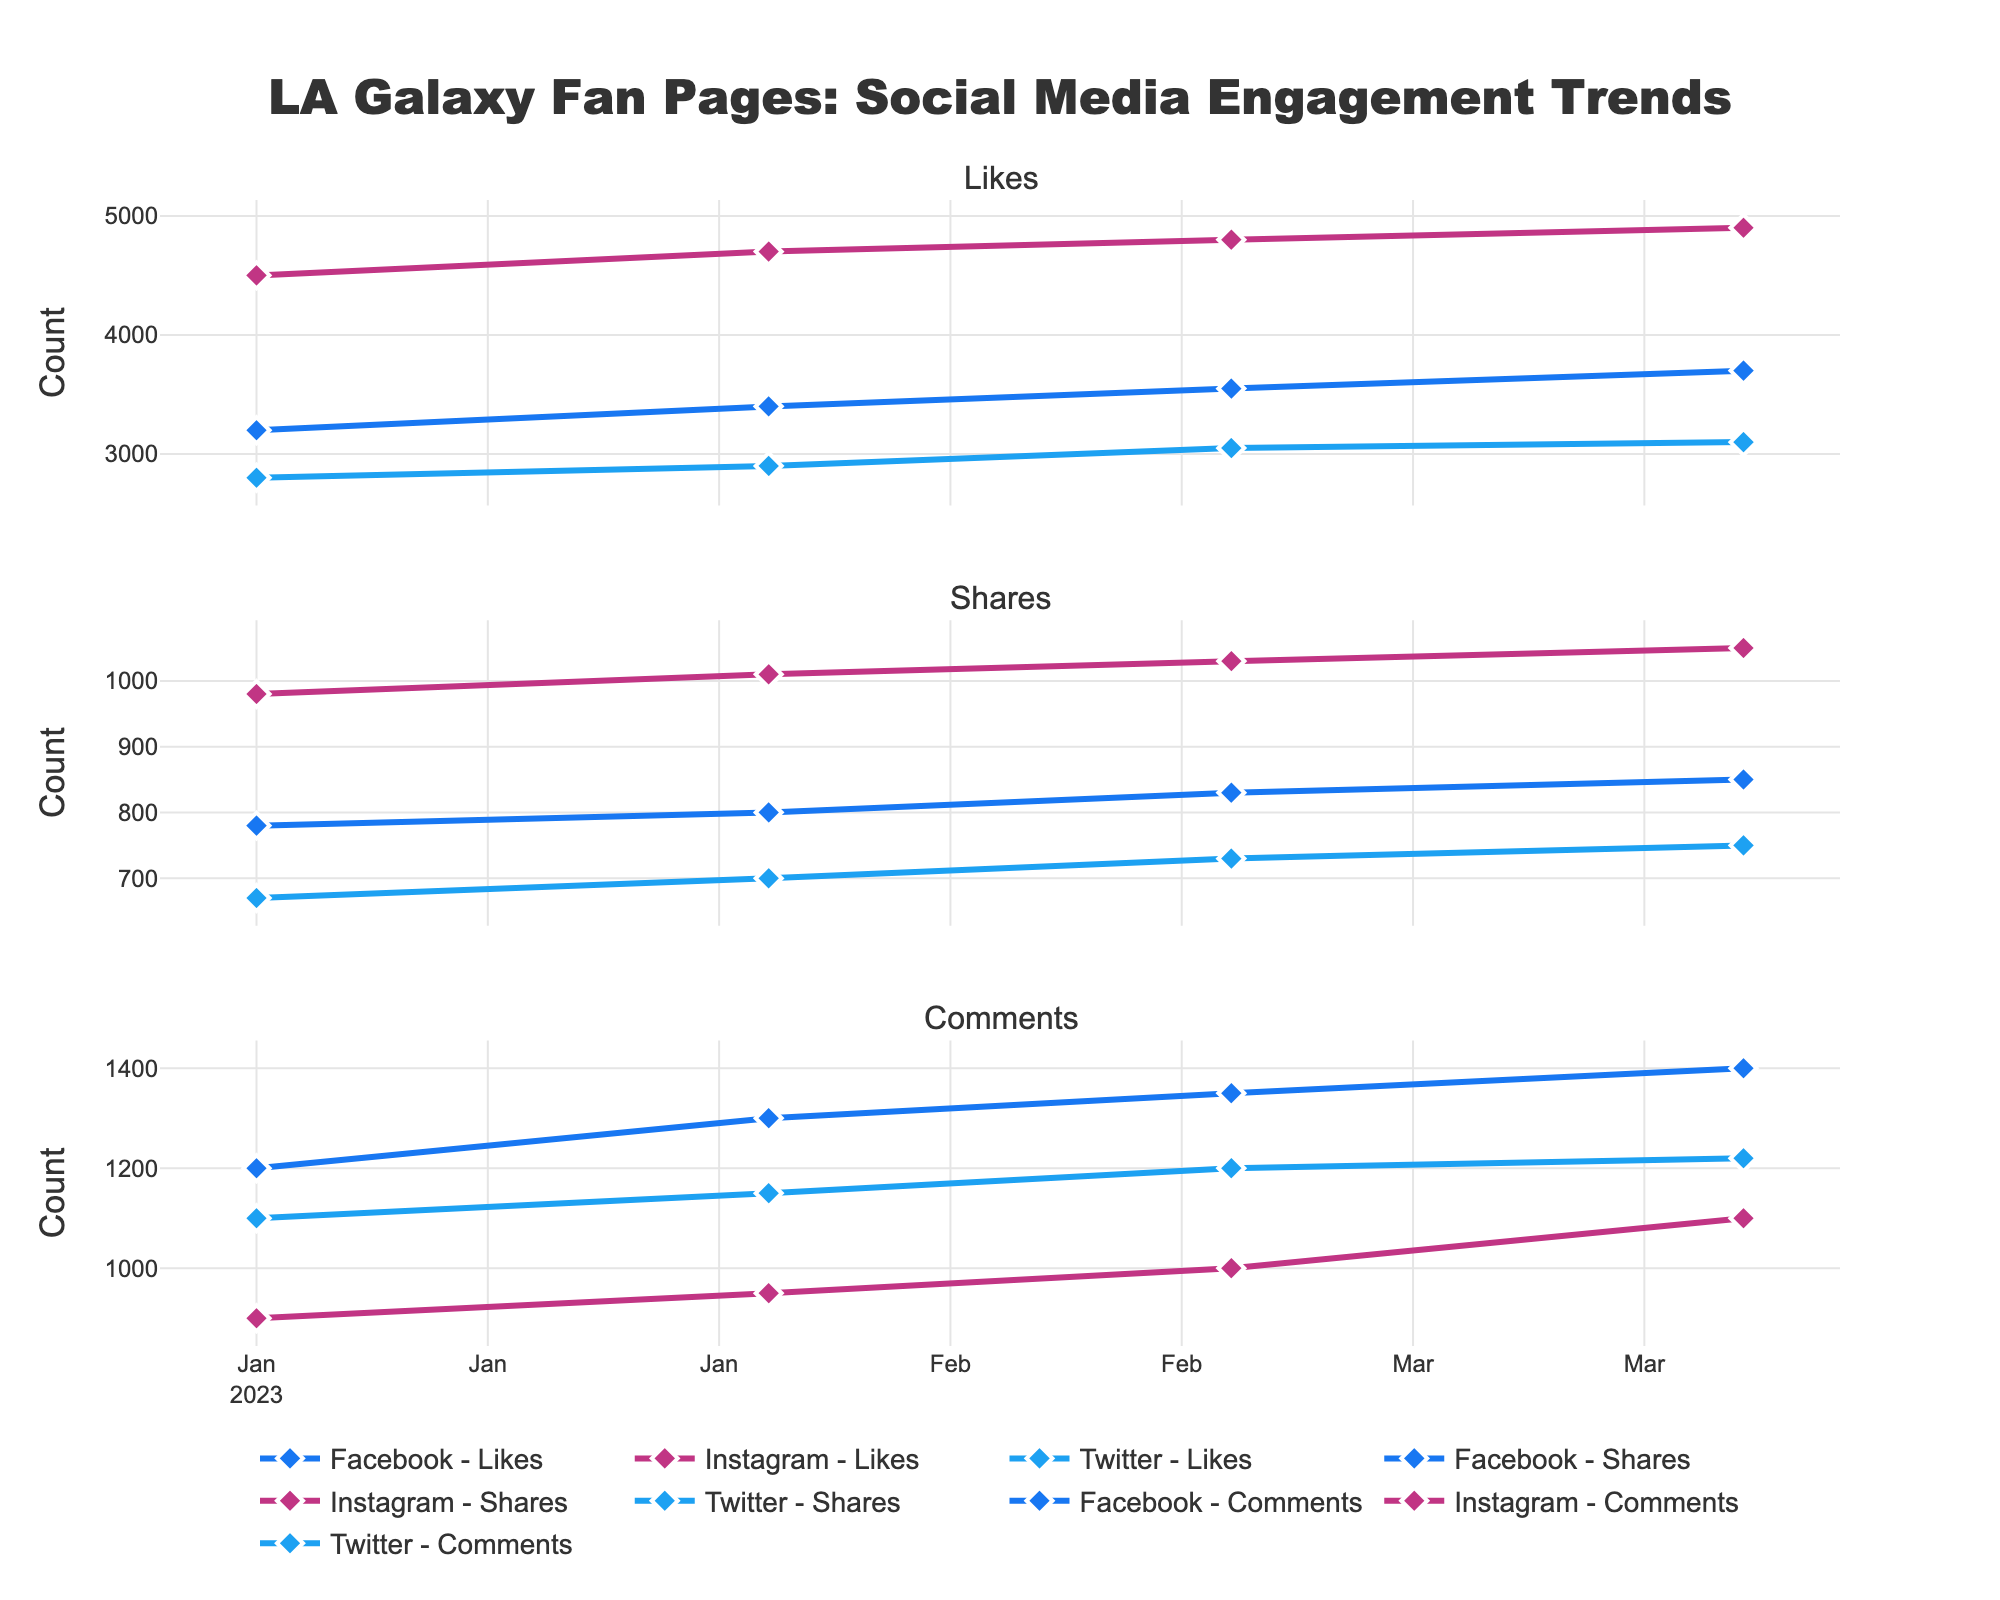What's the title of the figure? The title is generally placed at the top of the figure. In this case, the title as per the code provided is "LA Galaxy Fan Pages: Social Media Engagement Trends".
Answer: LA Galaxy Fan Pages: Social Media Engagement Trends What social media platform has the highest number of likes in April 2023? Referring to the plot for the month of April 2023, checking all platforms (Facebook, Instagram, Twitter) for the highest likes. Instagram has 4900 likes, which is higher than Facebook (3700) and Twitter (3100).
Answer: Instagram How many shares were there on Facebook in January 2023? Locate the data point for shares on Facebook in January 2023. According to the data, Facebook had 780 shares in January 2023.
Answer: 780 What is the trend of comments on Instagram from January to April 2023? Examine the time series for Instagram comments from January to April 2023. The counts are 900 in January, 950 in February, 1000 in March, and 1100 in April, showing a consistent increase.
Answer: Increasing Which month had the highest engagement in terms of likes across all platforms? Calculate the total number of likes for each month across all platforms and find the month with the highest total. In April 2023: Facebook (3700) + Instagram (4900) + Twitter (3100) = 11700, which is the highest.
Answer: April 2023 Compare the trend of Twitter comments to Facebook comments from January to April 2023. Plot the trend lines for Twitter and Facebook comments from January to April. Both trends show an increase, though Facebook has a steadier growth (1200 to 1400), and Twitter has a slower rate of increase (1100 to 1220).
Answer: Both are increasing; Facebook has a steadier growth What are the average likes for Instagram from January to April 2023? Calculate the average likes by summing the monthly values and dividing by the number of months: (4500 + 4700 + 4800 + 4900)/4 = 4725.
Answer: 4725 Which platform had the least shares in February 2023? Compare the shares in February 2023 for Facebook (800), Instagram (1010), and Twitter (700). Twitter had the least shares.
Answer: Twitter What is the difference in the number of shares between Instagram and Facebook in March 2023? Find the shares for Instagram (1030) and Facebook (830) in March 2023, then subtract: 1030 - 830 = 200.
Answer: 200 Is there a month where any platform has a decline in the number of likes? Review the time series to check for a decreasing trend in any platform. Each platform's likes increase month-to-month from January to April.
Answer: No 